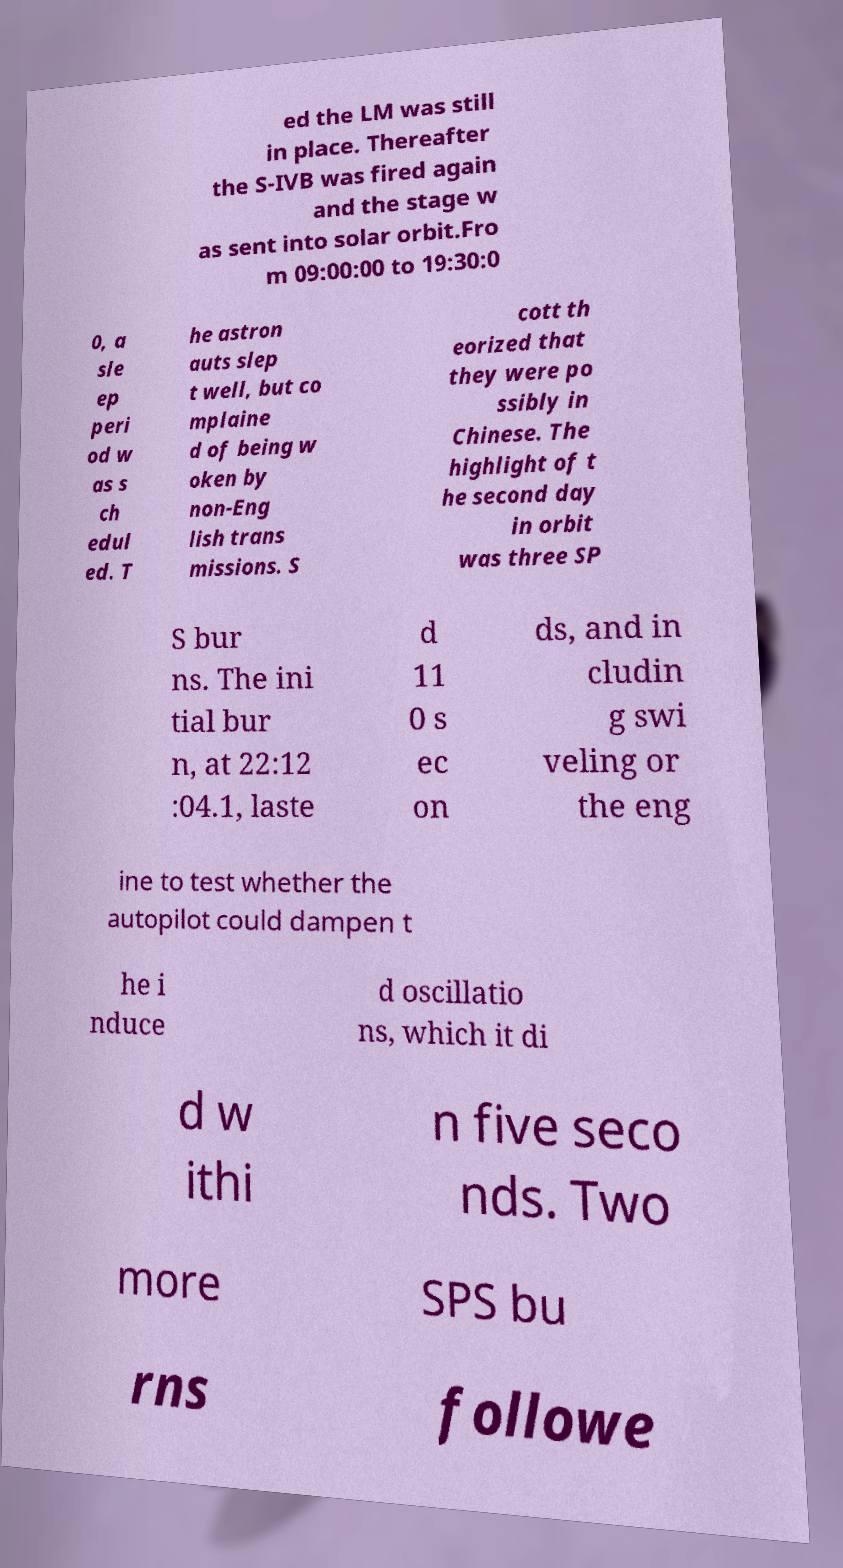Please identify and transcribe the text found in this image. ed the LM was still in place. Thereafter the S-IVB was fired again and the stage w as sent into solar orbit.Fro m 09:00:00 to 19:30:0 0, a sle ep peri od w as s ch edul ed. T he astron auts slep t well, but co mplaine d of being w oken by non-Eng lish trans missions. S cott th eorized that they were po ssibly in Chinese. The highlight of t he second day in orbit was three SP S bur ns. The ini tial bur n, at 22:12 :04.1, laste d 11 0 s ec on ds, and in cludin g swi veling or the eng ine to test whether the autopilot could dampen t he i nduce d oscillatio ns, which it di d w ithi n five seco nds. Two more SPS bu rns followe 